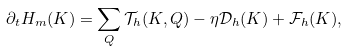<formula> <loc_0><loc_0><loc_500><loc_500>\partial _ { t } { H } _ { m } ( K ) = \sum _ { Q } { \mathcal { T } } _ { h } ( K , Q ) - \eta { \mathcal { D } } _ { h } ( K ) + { \mathcal { F } } _ { h } ( K ) ,</formula> 